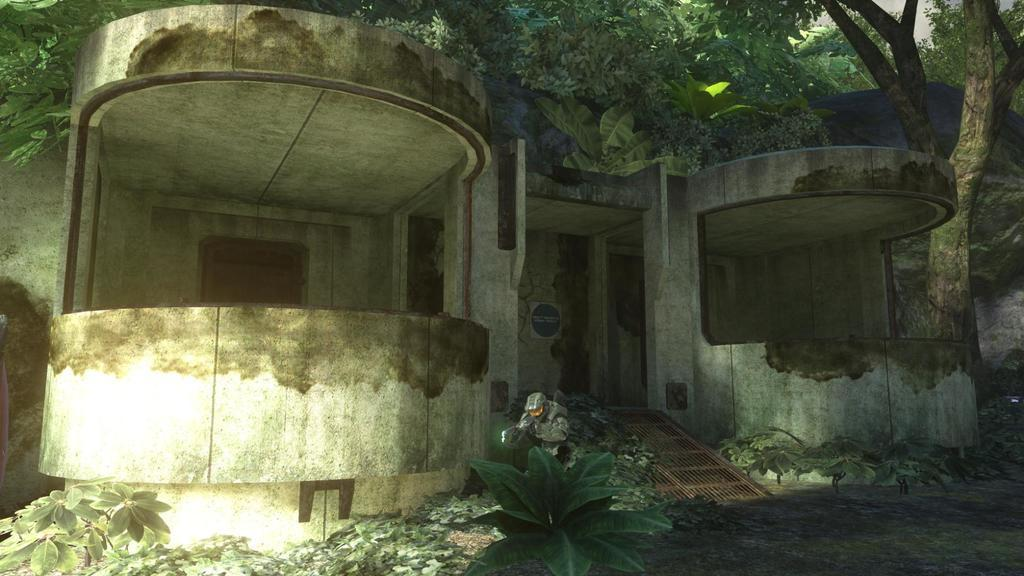What type of structure is visible in the image? There is a building in the image. Can you describe the location of the building in relation to other objects? The building is beside a tree. What other natural elements can be seen in the image? There are plants at the bottom of the image. How many eyes can be seen on the spade in the image? There is no spade or eye present in the image. What type of hole is visible in the image? There is no hole visible in the image. 